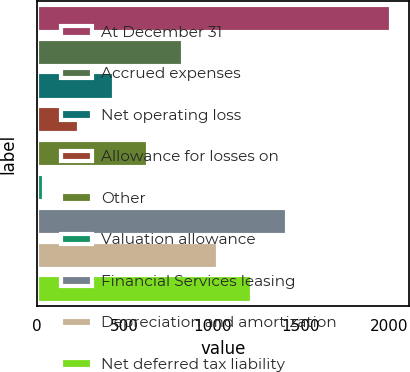<chart> <loc_0><loc_0><loc_500><loc_500><bar_chart><fcel>At December 31<fcel>Accrued expenses<fcel>Net operating loss<fcel>Allowance for losses on<fcel>Other<fcel>Valuation allowance<fcel>Financial Services leasing<fcel>Depreciation and amortization<fcel>Net deferred tax liability<nl><fcel>2013<fcel>831.54<fcel>437.72<fcel>240.81<fcel>634.63<fcel>43.9<fcel>1422.27<fcel>1028.45<fcel>1225.36<nl></chart> 